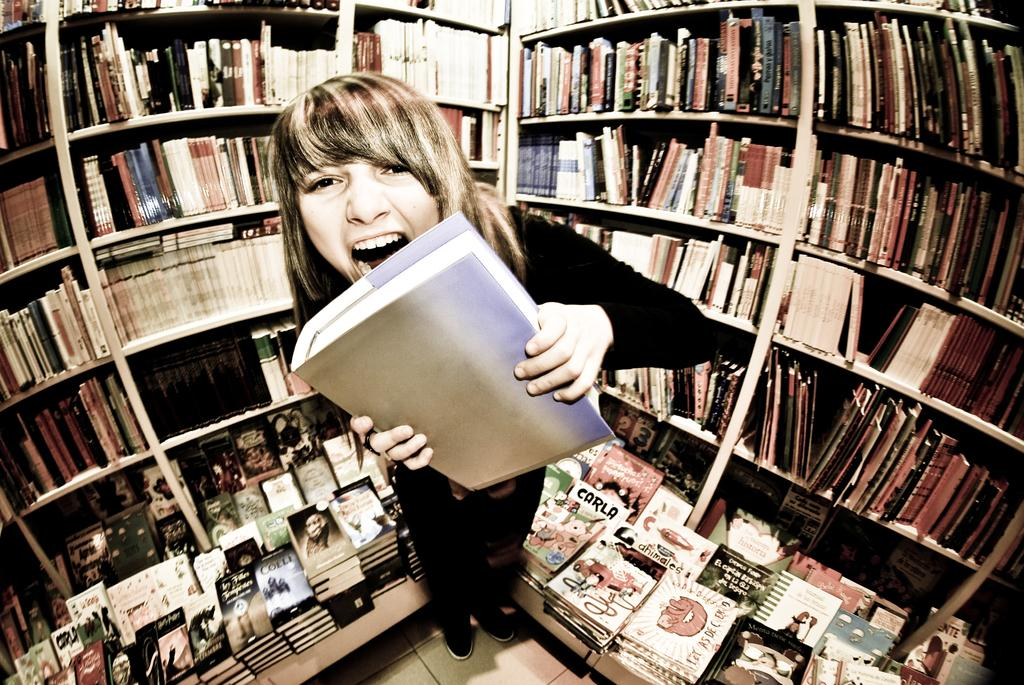What is the person in the image doing? The person is standing on the floor and holding a book. What can be seen in the background of the image? There are racks visible in the image. What is stored on the racks? There are books in the racks. Where is the kitten playing with the oven in the image? There is no kitten or oven present in the image. Can you see a stream flowing through the room in the image? There is no stream visible in the image. 